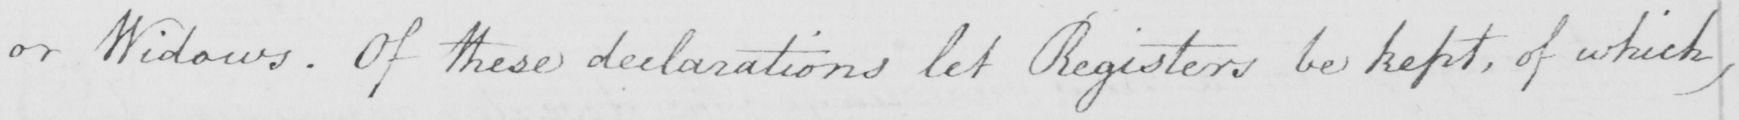Please transcribe the handwritten text in this image. or Widows. Of these declarations let Registers be kept, of which, 